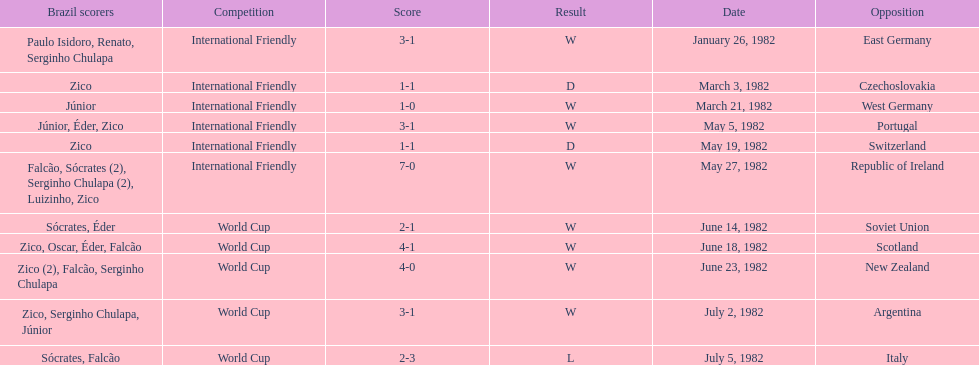Who was this team's next opponent after facing the soviet union on june 14? Scotland. 